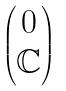Convert formula to latex. <formula><loc_0><loc_0><loc_500><loc_500>\begin{pmatrix} 0 \\ \mathbb { C } \end{pmatrix}</formula> 